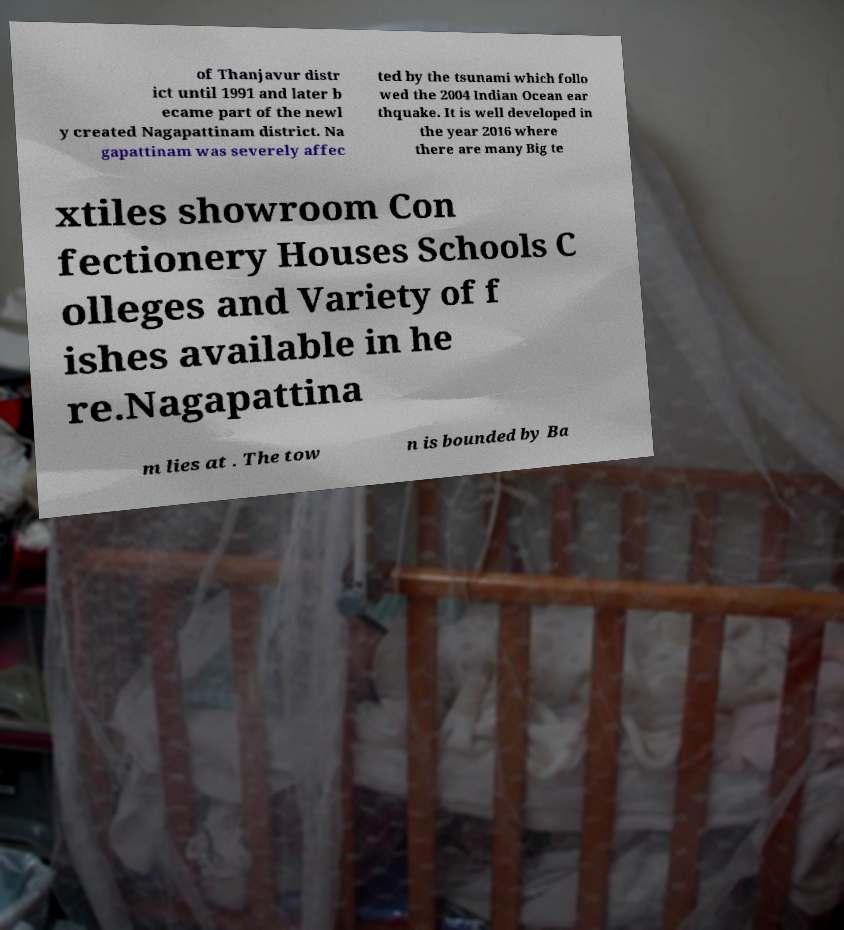What messages or text are displayed in this image? I need them in a readable, typed format. of Thanjavur distr ict until 1991 and later b ecame part of the newl y created Nagapattinam district. Na gapattinam was severely affec ted by the tsunami which follo wed the 2004 Indian Ocean ear thquake. It is well developed in the year 2016 where there are many Big te xtiles showroom Con fectionery Houses Schools C olleges and Variety of f ishes available in he re.Nagapattina m lies at . The tow n is bounded by Ba 